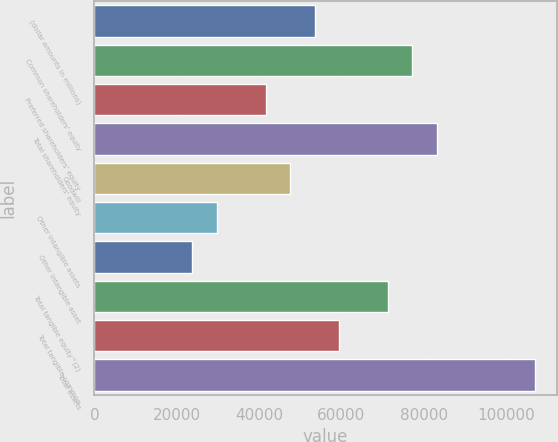<chart> <loc_0><loc_0><loc_500><loc_500><bar_chart><fcel>(dollar amounts in millions)<fcel>Common shareholders' equity<fcel>Preferred shareholders' equity<fcel>Total shareholders' equity<fcel>Goodwill<fcel>Other intangible assets<fcel>Other intangible asset<fcel>Total tangible equity^(2)<fcel>Total tangible common<fcel>Total assets<nl><fcel>53521.2<fcel>77304.5<fcel>41629.6<fcel>83250.3<fcel>47575.4<fcel>29737.9<fcel>23792.1<fcel>71358.7<fcel>59467<fcel>107034<nl></chart> 